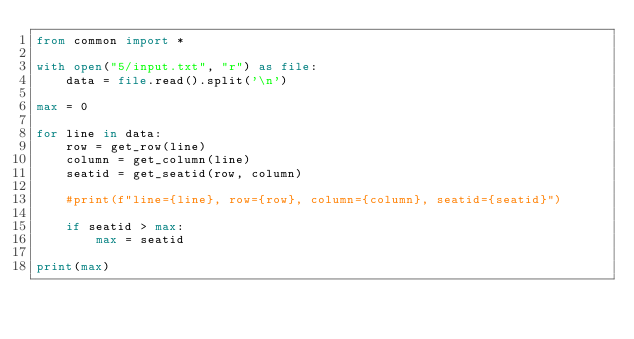<code> <loc_0><loc_0><loc_500><loc_500><_Python_>from common import *

with open("5/input.txt", "r") as file:
    data = file.read().split('\n')

max = 0

for line in data:
    row = get_row(line)
    column = get_column(line)
    seatid = get_seatid(row, column)

    #print(f"line={line}, row={row}, column={column}, seatid={seatid}")

    if seatid > max:
        max = seatid

print(max)
</code> 